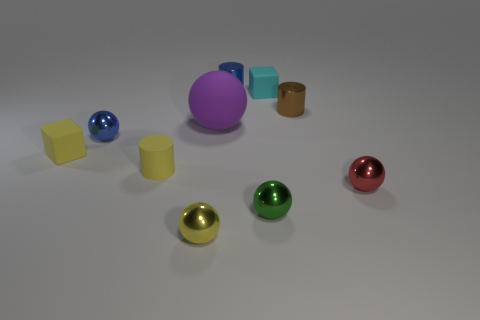Subtract all cylinders. How many objects are left? 7 Subtract all big rubber spheres. Subtract all balls. How many objects are left? 4 Add 5 metallic balls. How many metallic balls are left? 9 Add 7 big brown objects. How many big brown objects exist? 7 Subtract 0 green cylinders. How many objects are left? 10 